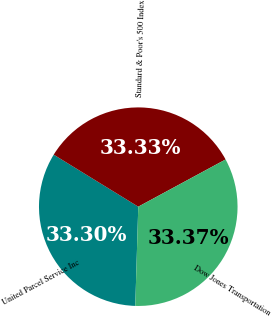<chart> <loc_0><loc_0><loc_500><loc_500><pie_chart><fcel>United Parcel Service Inc<fcel>Standard & Poor's 500 Index<fcel>Dow Jones Transportation<nl><fcel>33.3%<fcel>33.33%<fcel>33.37%<nl></chart> 